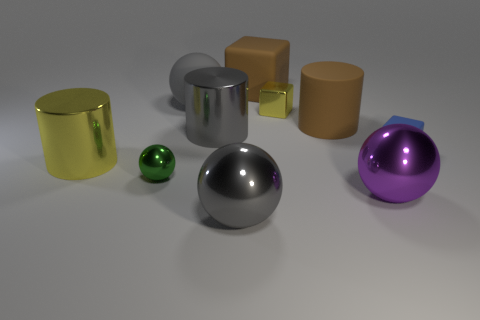Does the tiny metal block have the same color as the metallic cylinder that is to the left of the gray shiny cylinder?
Provide a short and direct response. Yes. There is a rubber block behind the gray rubber ball that is behind the green metal ball; what is its color?
Your response must be concise. Brown. Are there any large metal things behind the small metallic thing that is to the left of the gray sphere in front of the tiny green ball?
Give a very brief answer. Yes. There is a tiny cube that is the same material as the green thing; what color is it?
Keep it short and to the point. Yellow. How many big gray cylinders have the same material as the tiny green ball?
Offer a terse response. 1. Are the large brown cube and the ball that is behind the small blue cube made of the same material?
Offer a very short reply. Yes. How many things are either small shiny objects that are behind the yellow cylinder or gray spheres?
Provide a succinct answer. 3. There is a yellow metallic thing that is to the right of the gray metallic object in front of the sphere on the right side of the small yellow thing; how big is it?
Provide a short and direct response. Small. There is a object that is the same color as the large matte cube; what is it made of?
Provide a succinct answer. Rubber. There is a cylinder in front of the small object on the right side of the tiny yellow object; what size is it?
Your answer should be very brief. Large. 